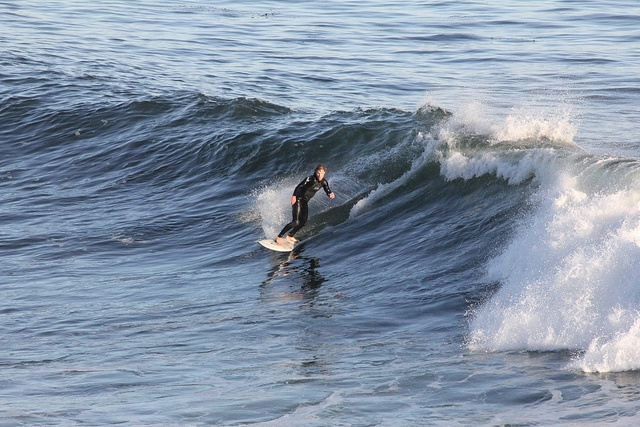Describe the objects in this image and their specific colors. I can see people in darkgray, black, gray, and tan tones and surfboard in darkgray, ivory, and tan tones in this image. 